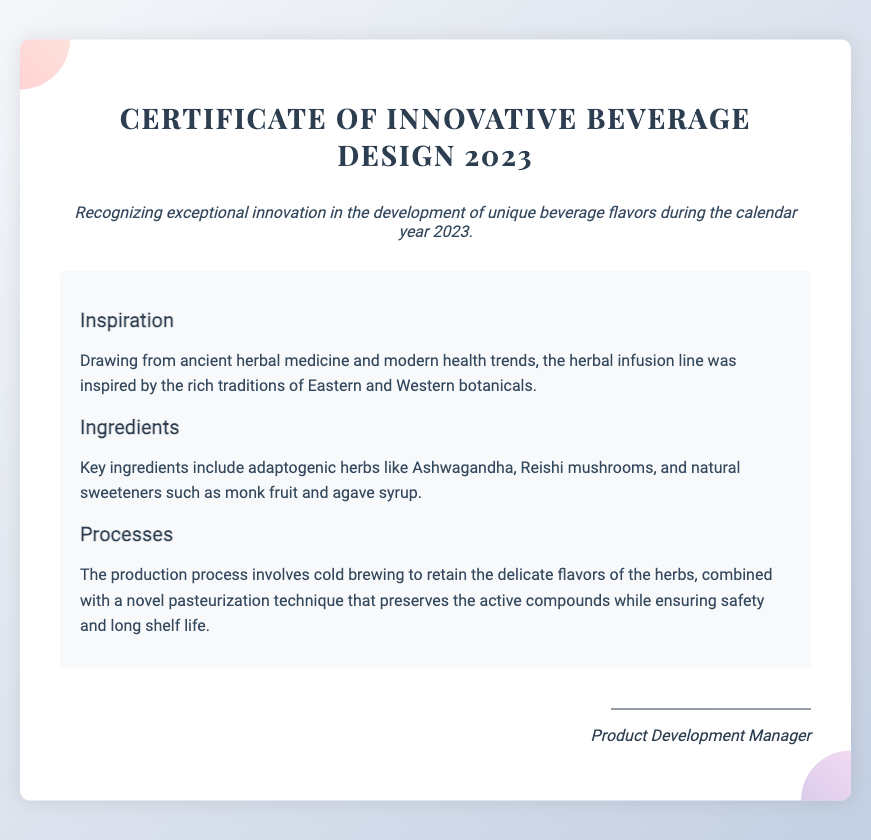What is the title of the certificate? The title of the certificate is prominently displayed at the top of the document, highlighting the award's purpose.
Answer: Certificate of Innovative Beverage Design 2023 What year is the certificate recognizing? The certificate specifically mentions the year for which the recognition is given.
Answer: 2023 What kind of flavors does the certificate focus on? The document states the specific area of achievement being recognized.
Answer: Unique beverage flavors What is one key ingredient mentioned in the certificate? The document lists specific ingredients used in the innovative beverage design.
Answer: Ashwagandha Which production method is highlighted in the document? The production process that retains delicate flavors while ensuring safety is outlined in the details.
Answer: Cold brewing What is the main inspiration for the beverage design? The document indicates the sources of inspiration for creating the beverage flavors.
Answer: Ancient herbal medicine and modern health trends What type of herbs are included in the beverage's ingredients? The document refers to a category of herbs used in the formulation of the beverage.
Answer: Adaptogenic herbs What does the certificate award recognize? The document specifies the achievement the certificate is acknowledging within beverage development.
Answer: Exceptional innovation in beverage design What is the role of the person signing the certificate? The signature section indicates the function or title of the person who will endorse the document.
Answer: Product Development Manager 